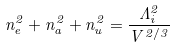Convert formula to latex. <formula><loc_0><loc_0><loc_500><loc_500>n _ { e } ^ { 2 } + n _ { a } ^ { 2 } + n _ { u } ^ { 2 } = \frac { \Lambda _ { i } ^ { 2 } } { V ^ { 2 / 3 } }</formula> 